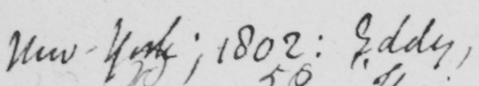Please transcribe the handwritten text in this image. New York ; 1802 :  Eddy , 